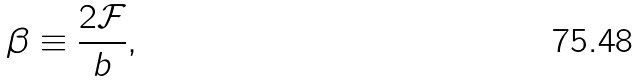<formula> <loc_0><loc_0><loc_500><loc_500>\beta \equiv \frac { 2 \mathcal { F } } { b } ,</formula> 